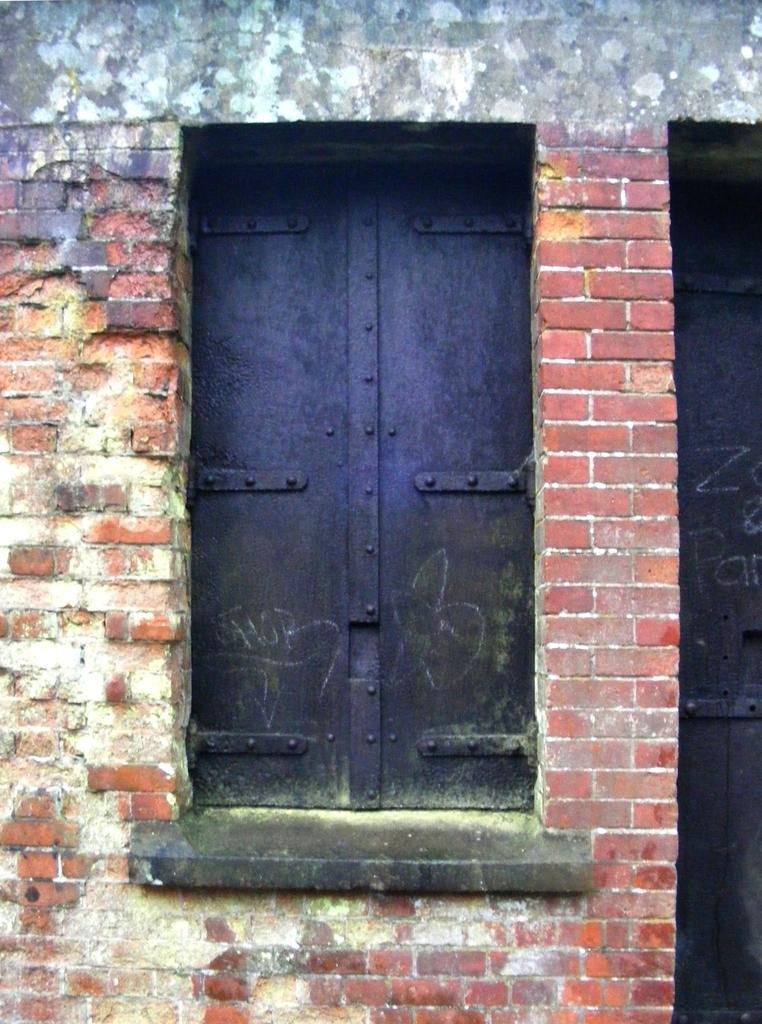Describe this image in one or two sentences. In this image there is a brick wall in the left and right corner. There is a metal window in the foreground. And there is a wall in the background. 